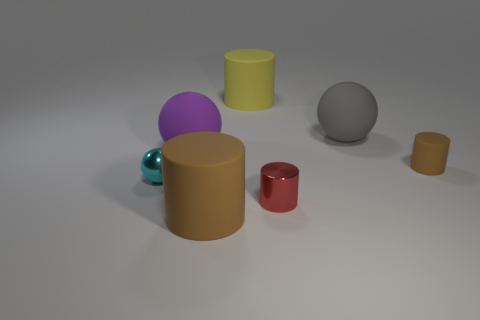Add 1 yellow matte things. How many objects exist? 8 Subtract all cylinders. How many objects are left? 3 Add 5 small things. How many small things exist? 8 Subtract 0 cyan blocks. How many objects are left? 7 Subtract all tiny purple balls. Subtract all tiny brown cylinders. How many objects are left? 6 Add 6 gray rubber balls. How many gray rubber balls are left? 7 